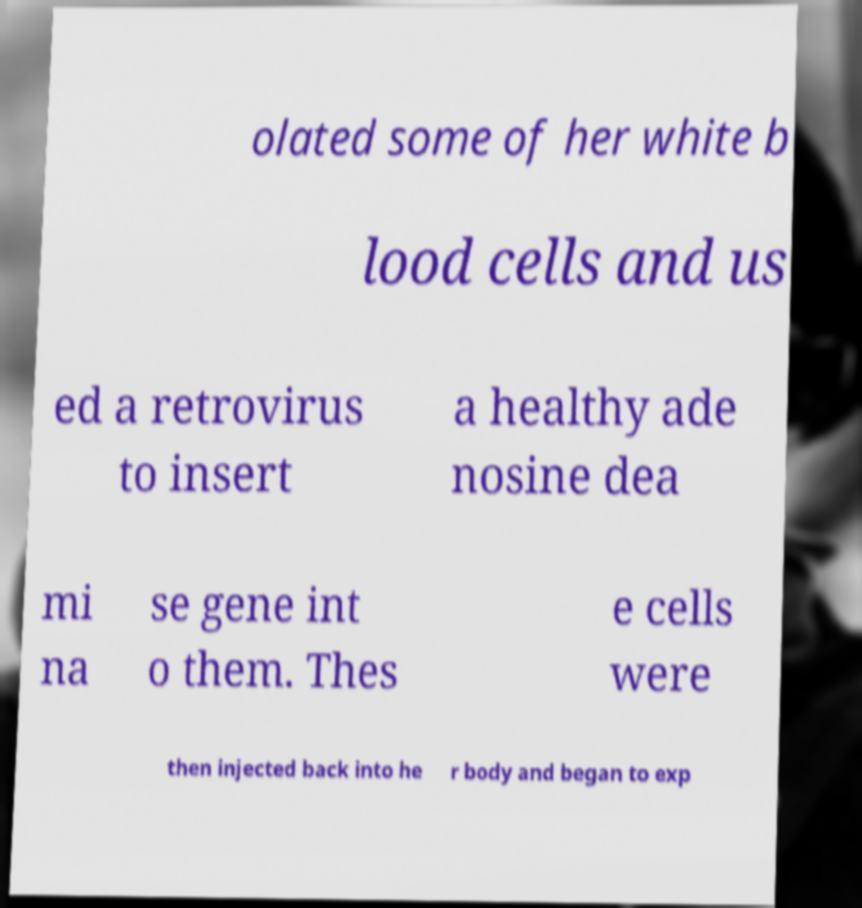Please identify and transcribe the text found in this image. olated some of her white b lood cells and us ed a retrovirus to insert a healthy ade nosine dea mi na se gene int o them. Thes e cells were then injected back into he r body and began to exp 